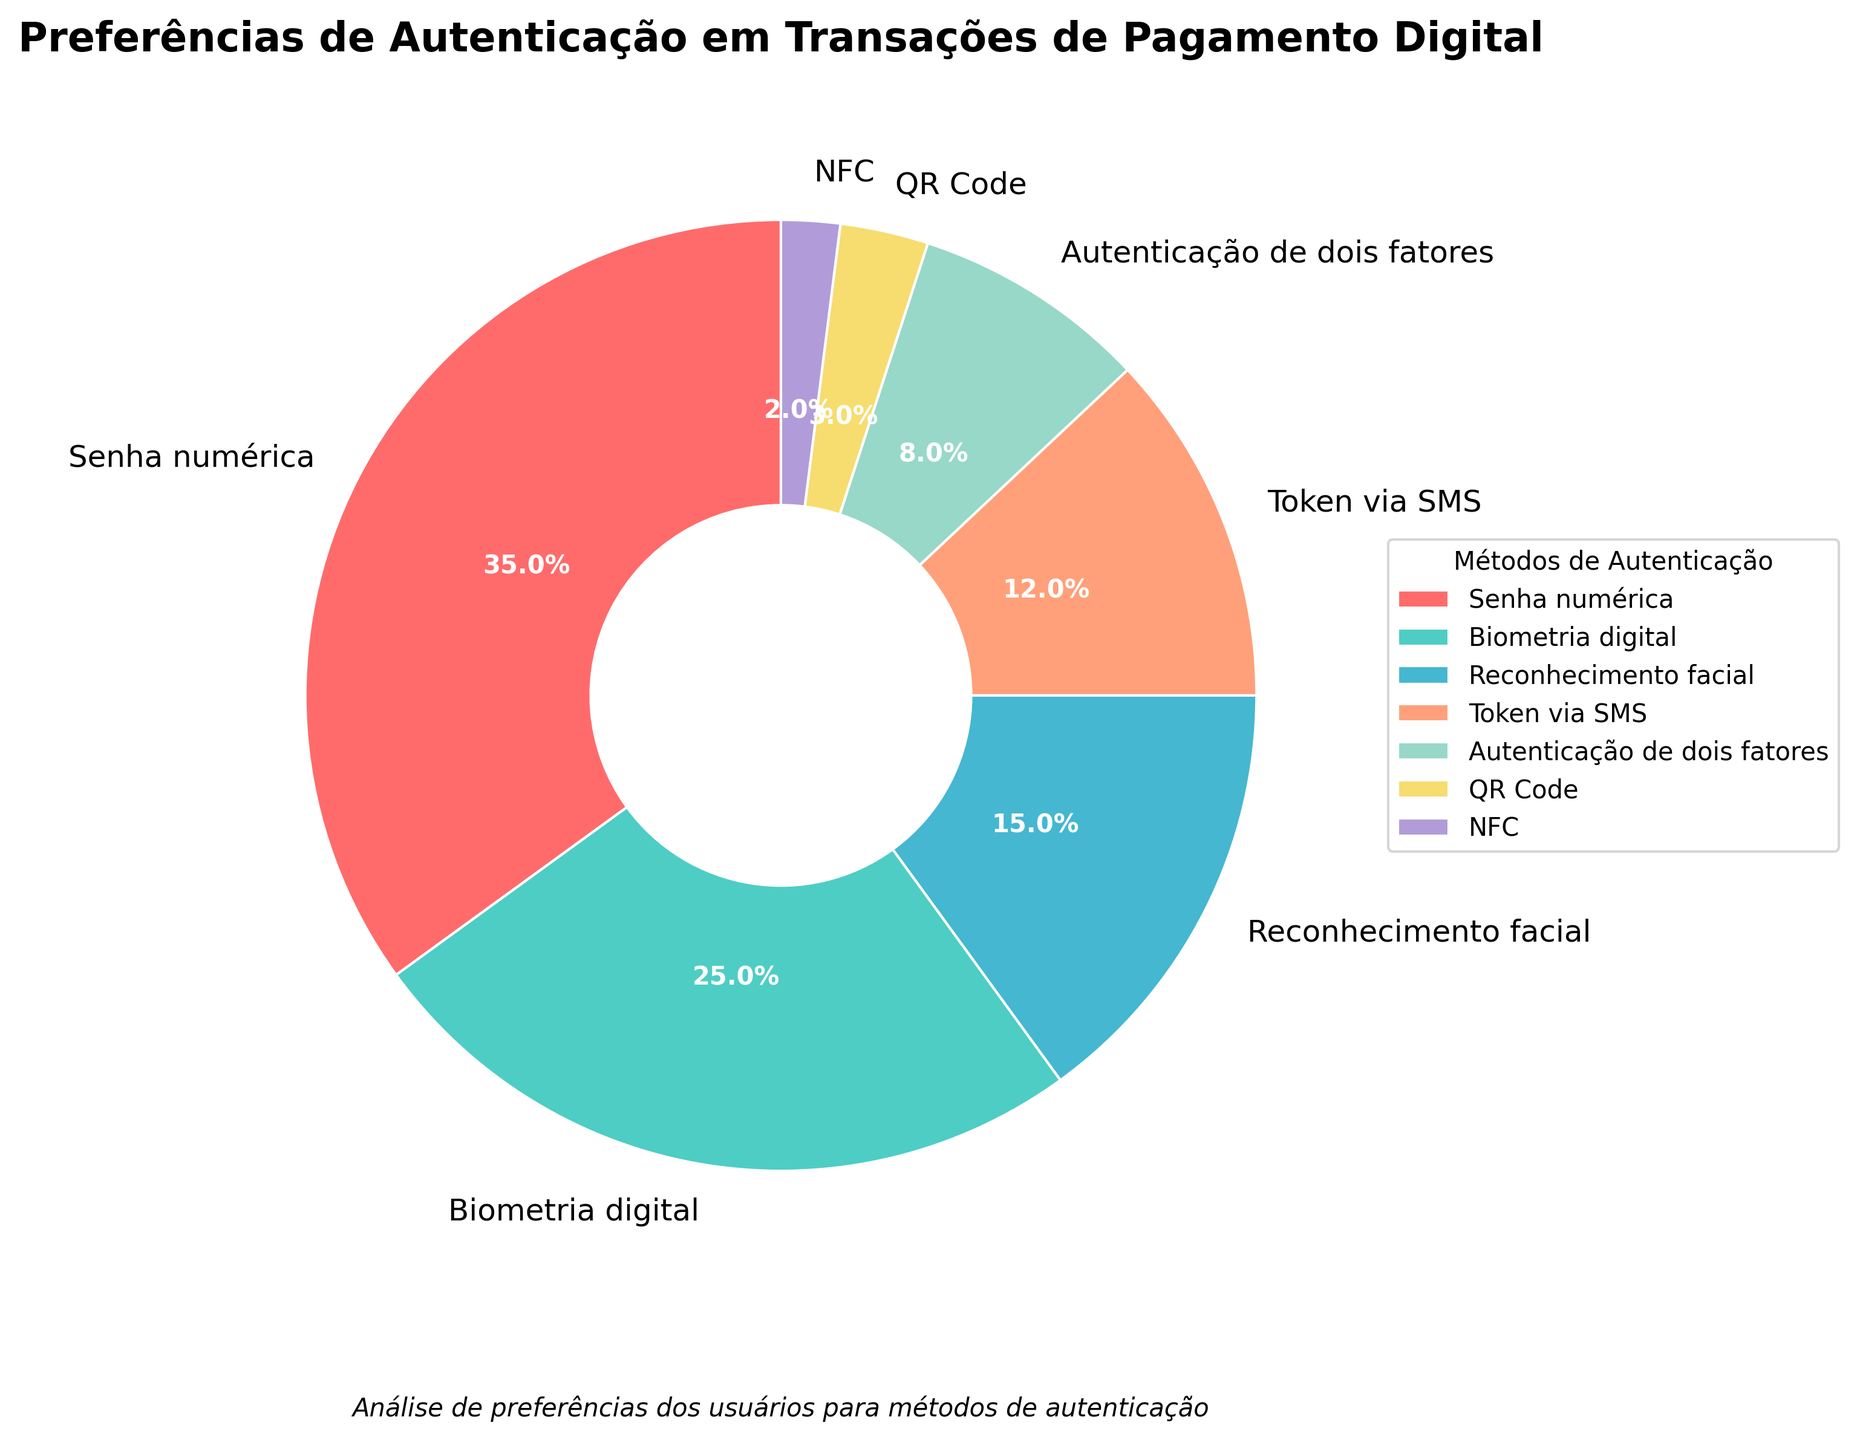Which authentication method is preferred by the largest percentage of users? To find the answer, refer to the segment of the pie chart with the largest size. The label indicates that the "Senha numérica" (Numeric password) holds 35% of preference.
Answer: Senha numérica What is the total percentage of users that prefer either biometric (digital) or facial recognition methods? Add the percentages of users preferring "Biometria digital" (25%) and "Reconhecimento facial" (15%). The total is 25% + 15% = 40%.
Answer: 40% How much more popular is the "Token via SMS" method compared to the "QR Code" method? Subtract the percentage for "QR Code" (3%) from the percentage for "Token via SMS" (12%). This gives 12% - 3% = 9%.
Answer: 9% Which authentication method has the smallest preference among users? Identify the smallest segment in the pie chart. The label indicates this is "NFC" with 2%.
Answer: NFC What is the combined percentage of users that prefer "Autenticação de dois fatores" and "NFC"? Add the percentages of users preferring "Autenticação de dois fatores" (8%) and "NFC" (2%). This gives 8% + 2% = 10%.
Answer: 10% Between "Biometria digital" and "Token via SMS", which method is more popular and by how much? Compare the percentages. "Biometria digital" has 25% and "Token via SMS" has 12%. Subtracting these gives 25% - 12% = 13%.
Answer: Biometria digital by 13% What percentage of users prefer methods other than "Senha numérica"? Subtract the percentage of users preferring "Senha numérica" (35%) from 100%. This gives 100% - 35% = 65%.
Answer: 65% Which methods combined have a lower preference than "Reconhecimento facial"? Identify all methods with percentages lower than "Reconhecimento facial" (15%): "Token via SMS" (12%), "Autenticação de dois fatores" (8%), "QR Code" (3%), and "NFC" (2%). Adding these gives 12% + 8% + 3% + 2% = 25%.
Answer: Token via SMS, Autenticação de dois fatores, QR Code, NFC What is the average percentage preference for "Senha numérica", "Biometria digital", and "Reconhecimento facial"? Sum the percentages for these methods: 35% (Senha numérica), 25% (Biometria digital), and 15% (Reconhecimento facial). The total is 35% + 25% + 15% = 75%. Divide by the number of methods, 75% / 3 ≈ 25%.
Answer: 25% How much larger is the segment representing "Biometria digital" compared to the one for "Autenticação de dois fatores" in percentage points? Subtract the percentage for "Autenticação de dois fatores" (8%) from the percentage for "Biometria digital" (25%). This gives 25% - 8% = 17%.
Answer: 17% 